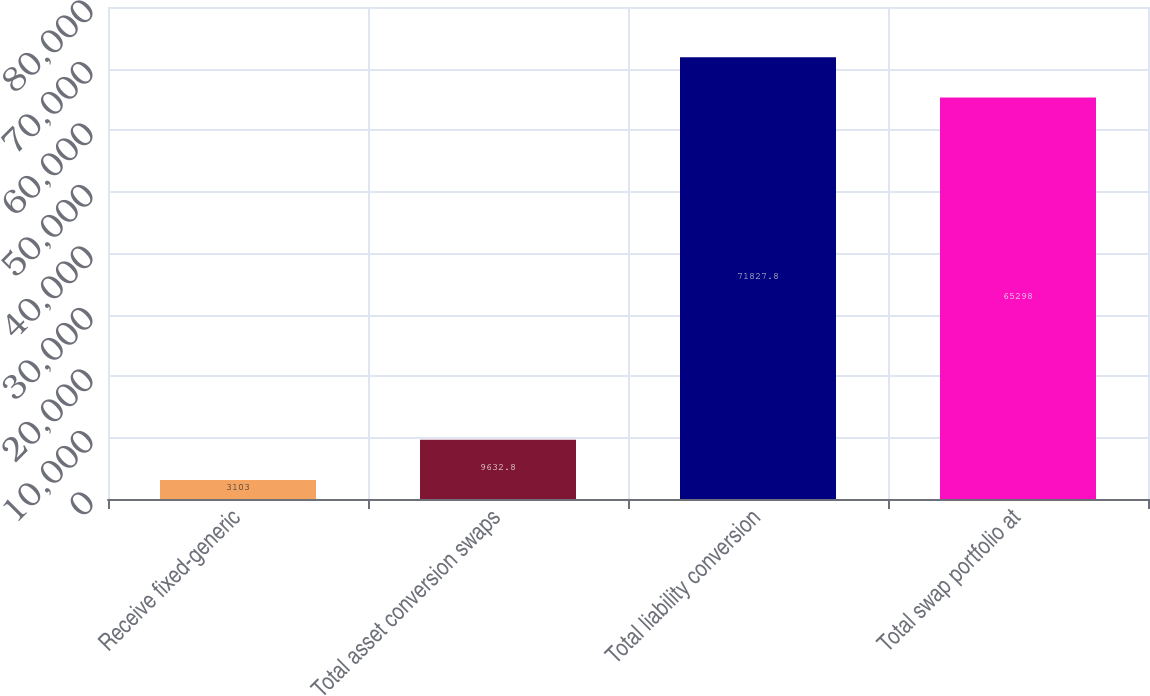<chart> <loc_0><loc_0><loc_500><loc_500><bar_chart><fcel>Receive fixed-generic<fcel>Total asset conversion swaps<fcel>Total liability conversion<fcel>Total swap portfolio at<nl><fcel>3103<fcel>9632.8<fcel>71827.8<fcel>65298<nl></chart> 